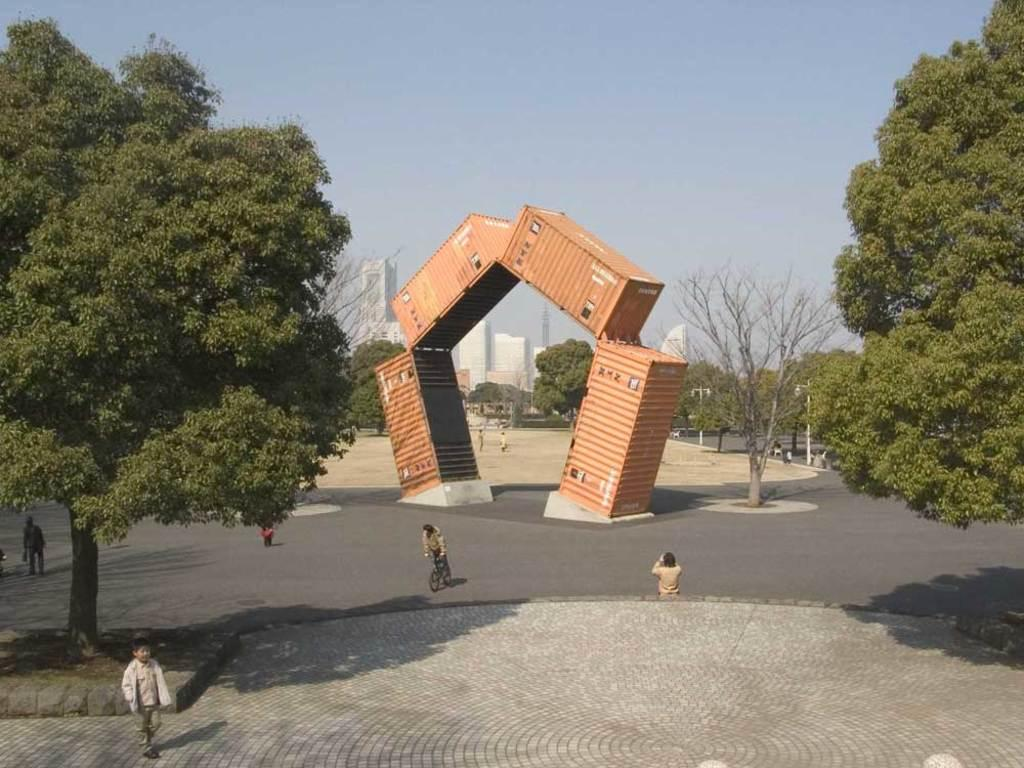What type of vegetation is present on both sides of the image? There are trees on both sides of the image. What architectural feature can be seen in the image? There is an arch in the image. What is happening on the road in the image? There are people on the road in the image. What can be seen in the background of the image? There are trees and buildings in the background of the image. What is the condition of the sky in the image? The sky is clear in the image. Are there any ghosts visible in the image? There are no ghosts present in the image. What type of writer can be seen working on a novel in the image? There is no writer present in the image. How many sheep are visible in the image? There are no sheep present in the image. 